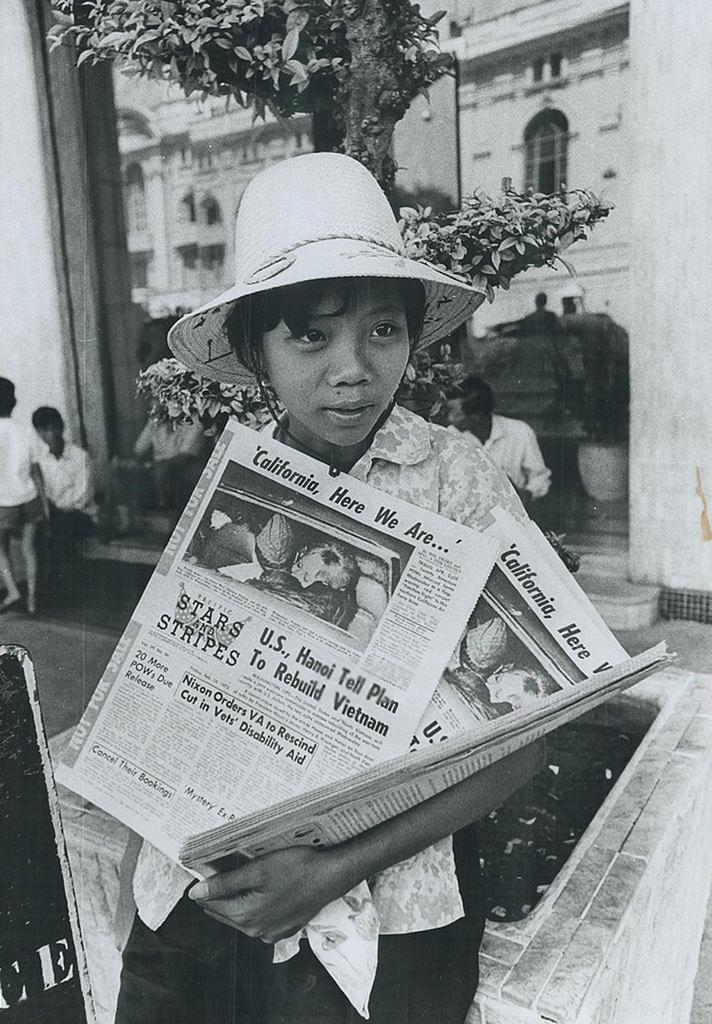Who is the main subject in the image? There is a girl in the image. What is the girl doing in the image? The girl is standing and holding newspapers. What is the girl wearing on her head? The girl is wearing a cap. What can be seen in the background of the image? There is a building in the background of the image. How many more persons are present in the image besides the girl? There are two more persons in the image. What type of lettuce is being used as a prop in the meeting depicted in the image? There is no meeting or lettuce present in the image. What type of laborer is shown working in the background of the image? There is no laborer or work-related activity depicted in the image. 